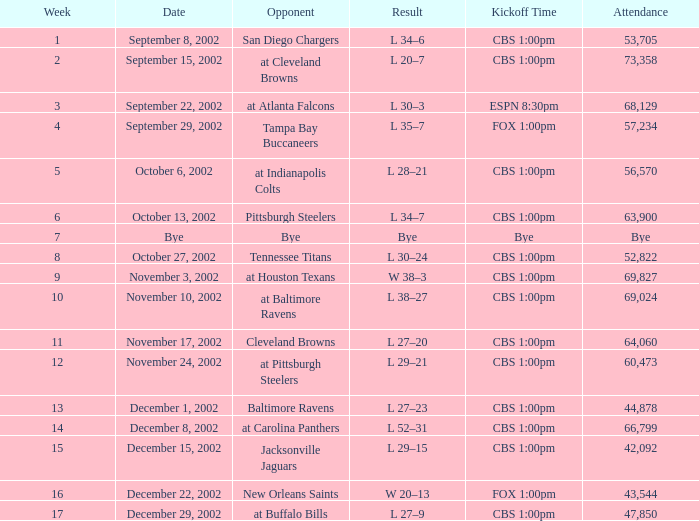When was the week the rival team was the san diego chargers? 1.0. 